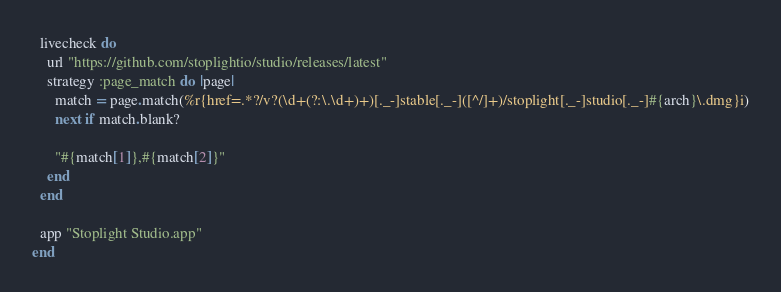<code> <loc_0><loc_0><loc_500><loc_500><_Ruby_>  livecheck do
    url "https://github.com/stoplightio/studio/releases/latest"
    strategy :page_match do |page|
      match = page.match(%r{href=.*?/v?(\d+(?:\.\d+)+)[._-]stable[._-]([^/]+)/stoplight[._-]studio[._-]#{arch}\.dmg}i)
      next if match.blank?

      "#{match[1]},#{match[2]}"
    end
  end

  app "Stoplight Studio.app"
end
</code> 